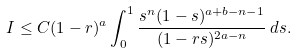<formula> <loc_0><loc_0><loc_500><loc_500>I \leq C ( 1 - r ) ^ { a } \int _ { 0 } ^ { 1 } \frac { s ^ { n } ( 1 - s ) ^ { a + b - n - 1 } } { ( 1 - r s ) ^ { 2 a - n } } \, d s .</formula> 